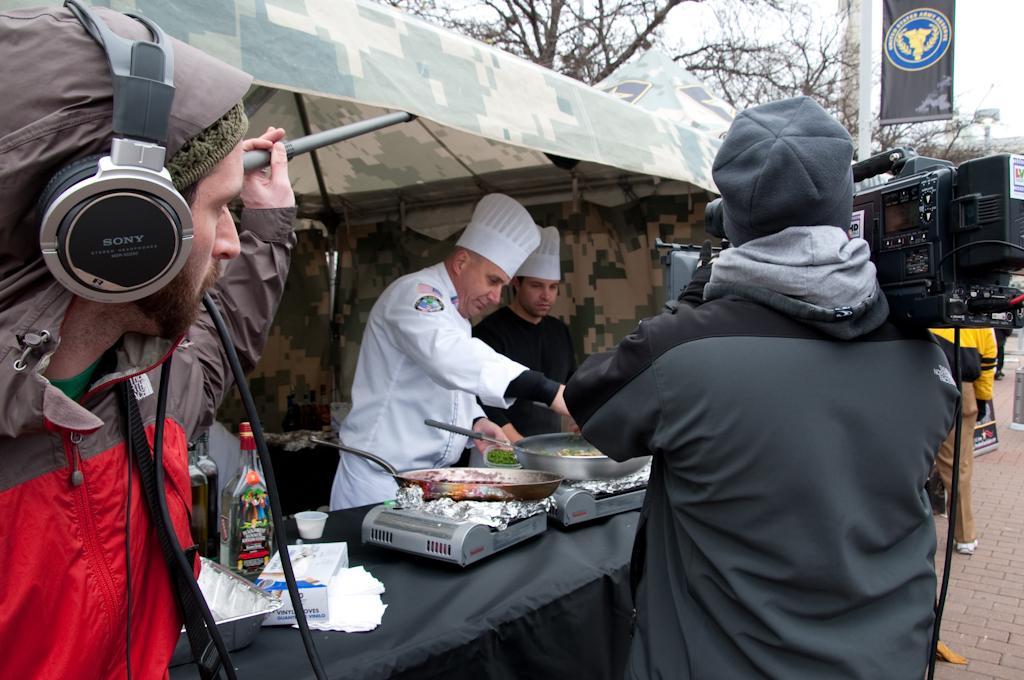Describe this image in one or two sentences. Here we can see few persons. He is holding a camera and he is preparing food. Here we can see a tablecloth, pan, stove, bottle, cup, tissue papers, tray and a box. This is stall and there are trees. Here we can see a banner, pole, and sky. 